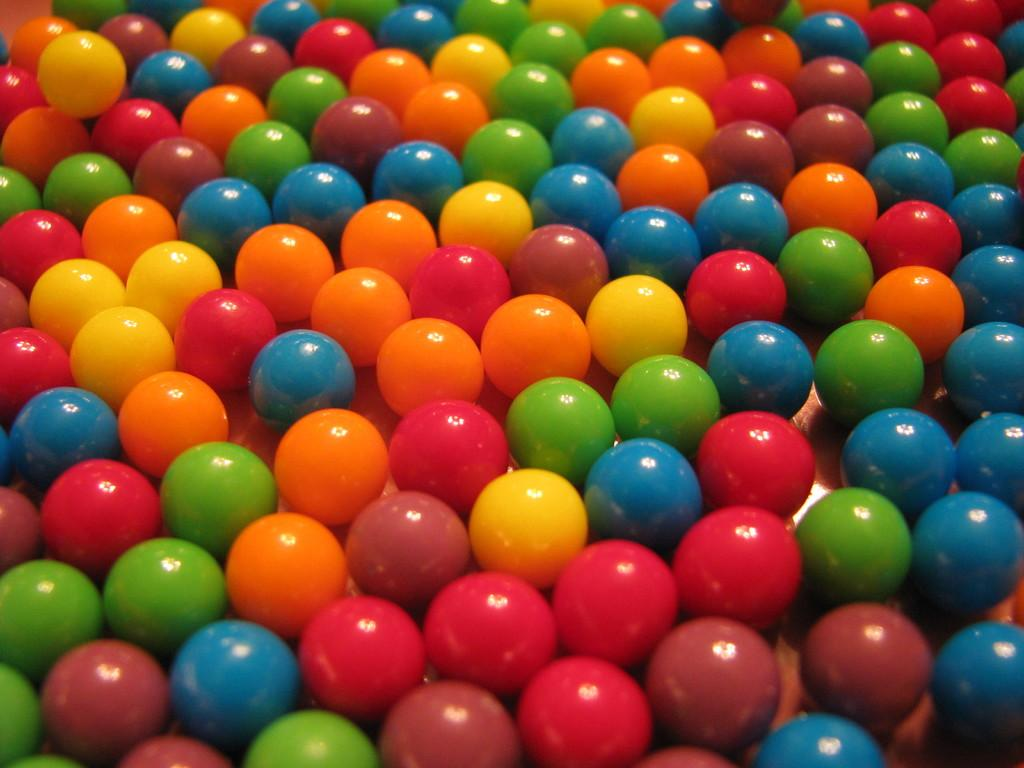What objects are present in the image? There are balls in the image. Can you describe the appearance of the balls? The balls have different colors. Where are the balls located in the image? The balls are on a surface. What word is written on the balls in the image? There is no word written on the balls in the image; they are just solid-colored balls. 